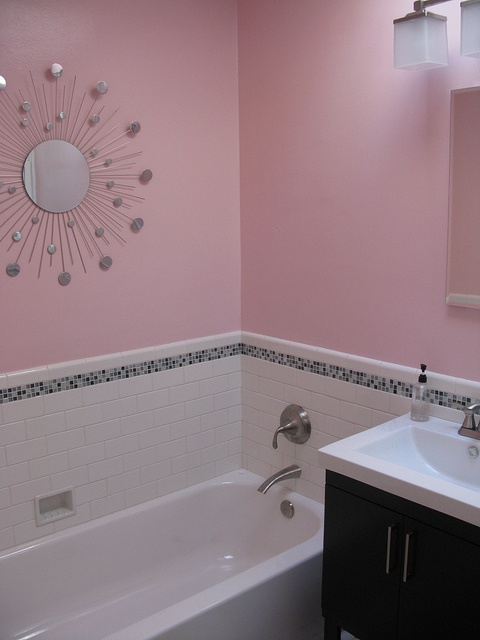Describe the objects in this image and their specific colors. I can see sink in gray, darkgray, and lavender tones and bottle in gray and black tones in this image. 